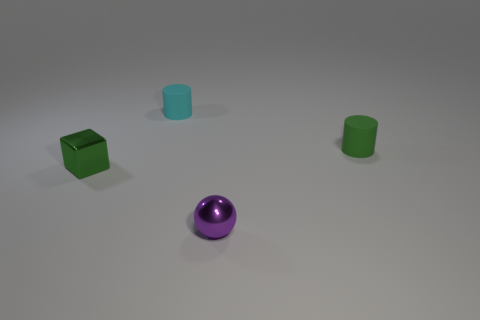Add 2 green things. How many objects exist? 6 Subtract all blocks. How many objects are left? 3 Add 4 tiny blue rubber balls. How many tiny blue rubber balls exist? 4 Subtract 0 red cylinders. How many objects are left? 4 Subtract all yellow metal blocks. Subtract all small spheres. How many objects are left? 3 Add 3 green blocks. How many green blocks are left? 4 